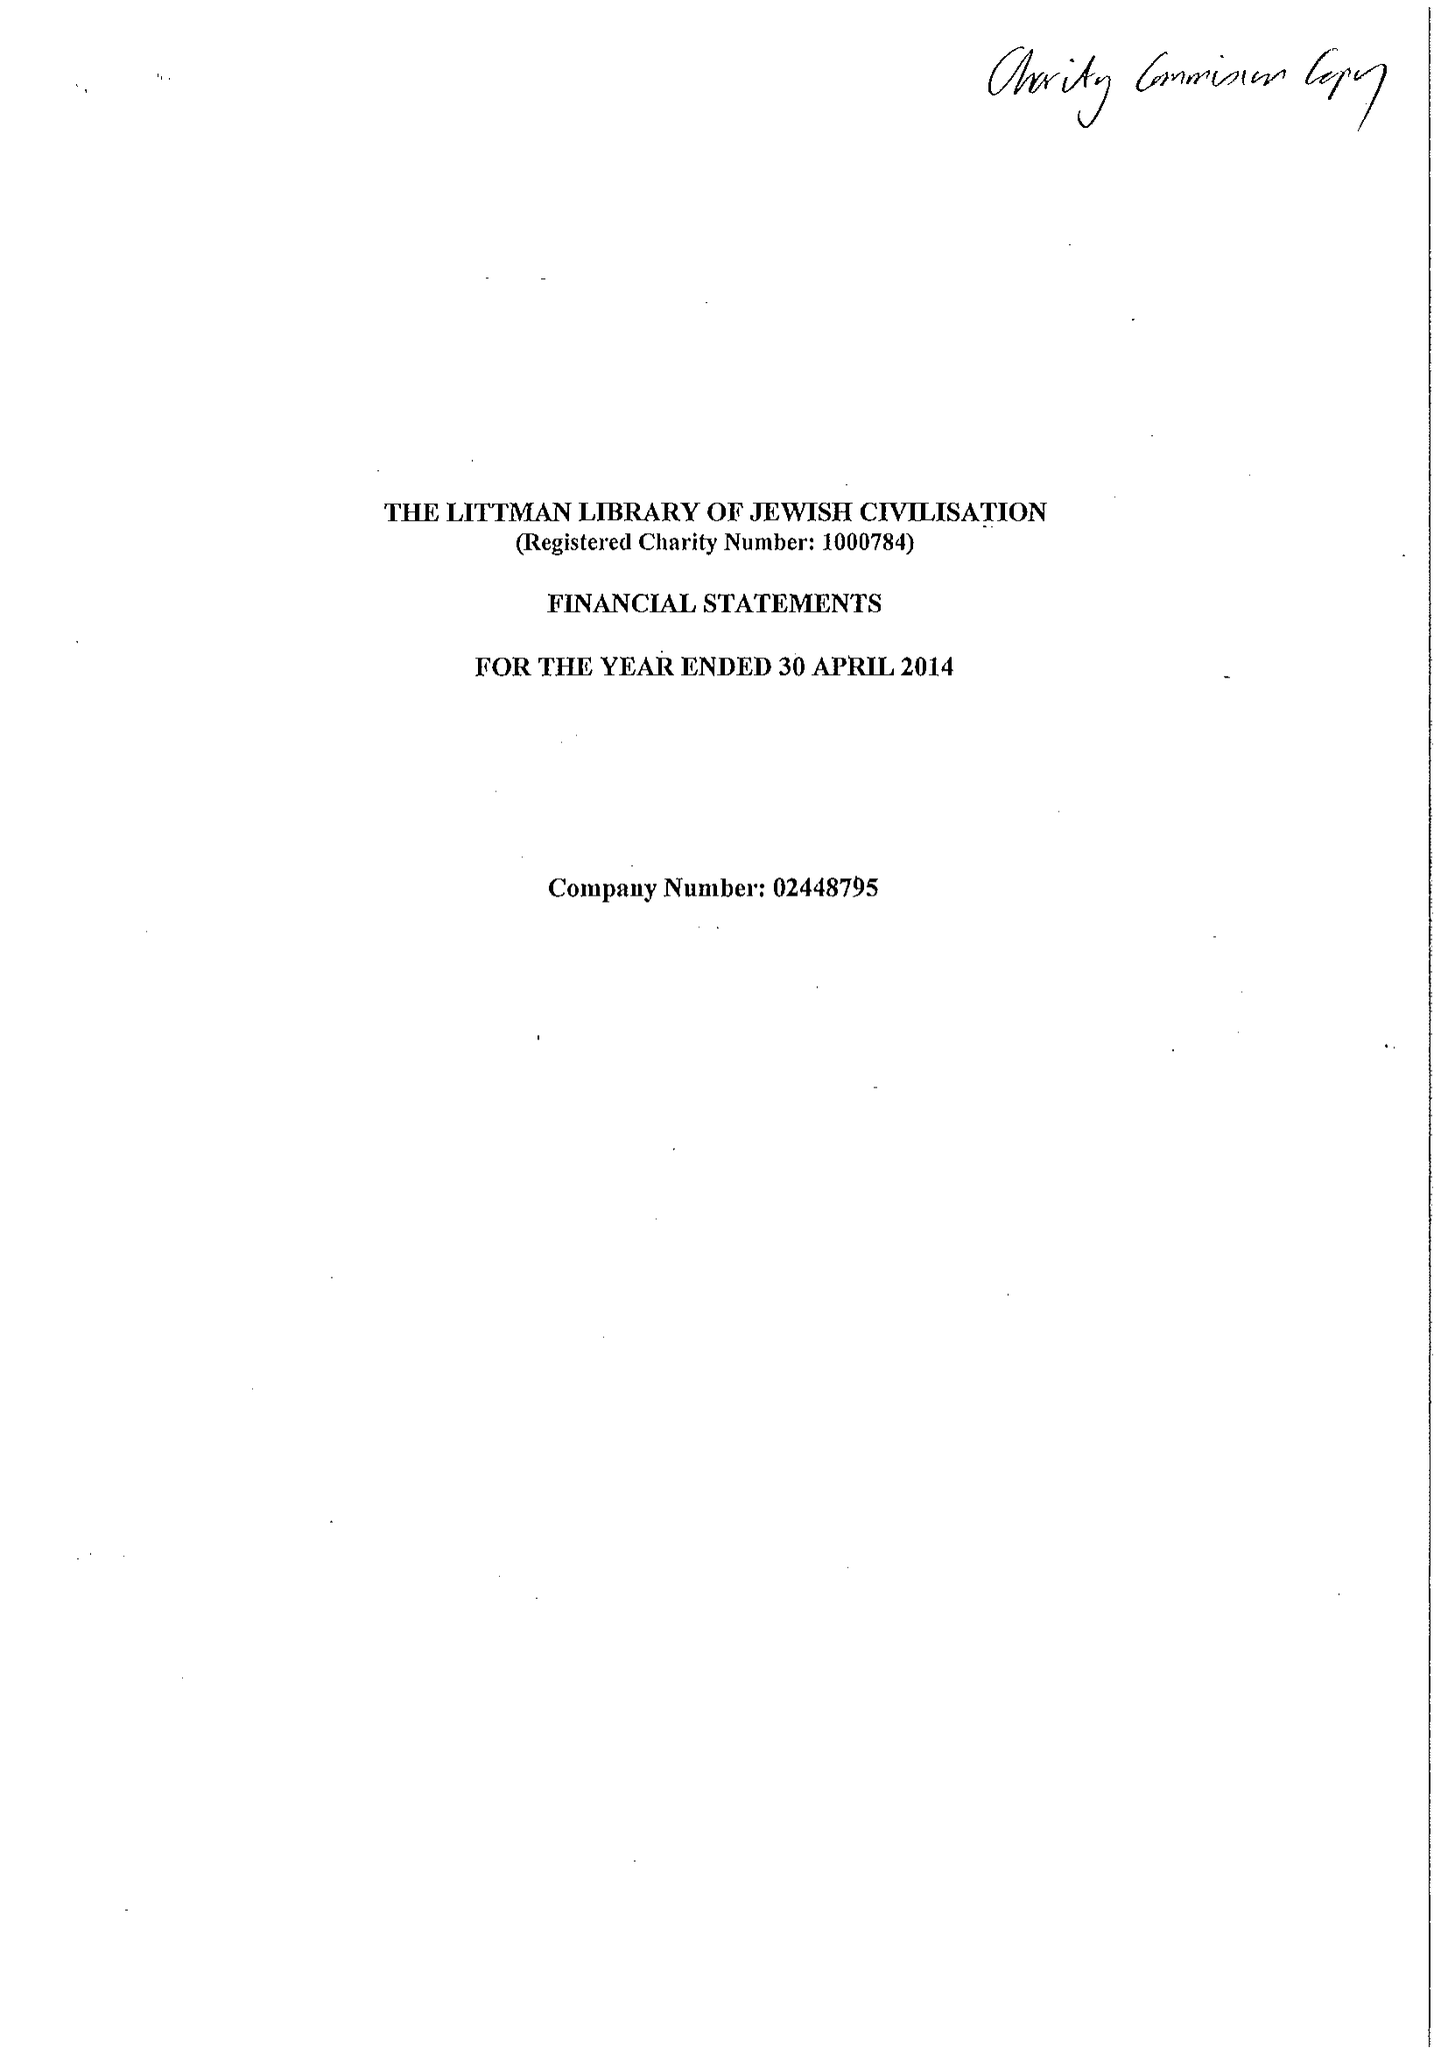What is the value for the address__street_line?
Answer the question using a single word or phrase. None 